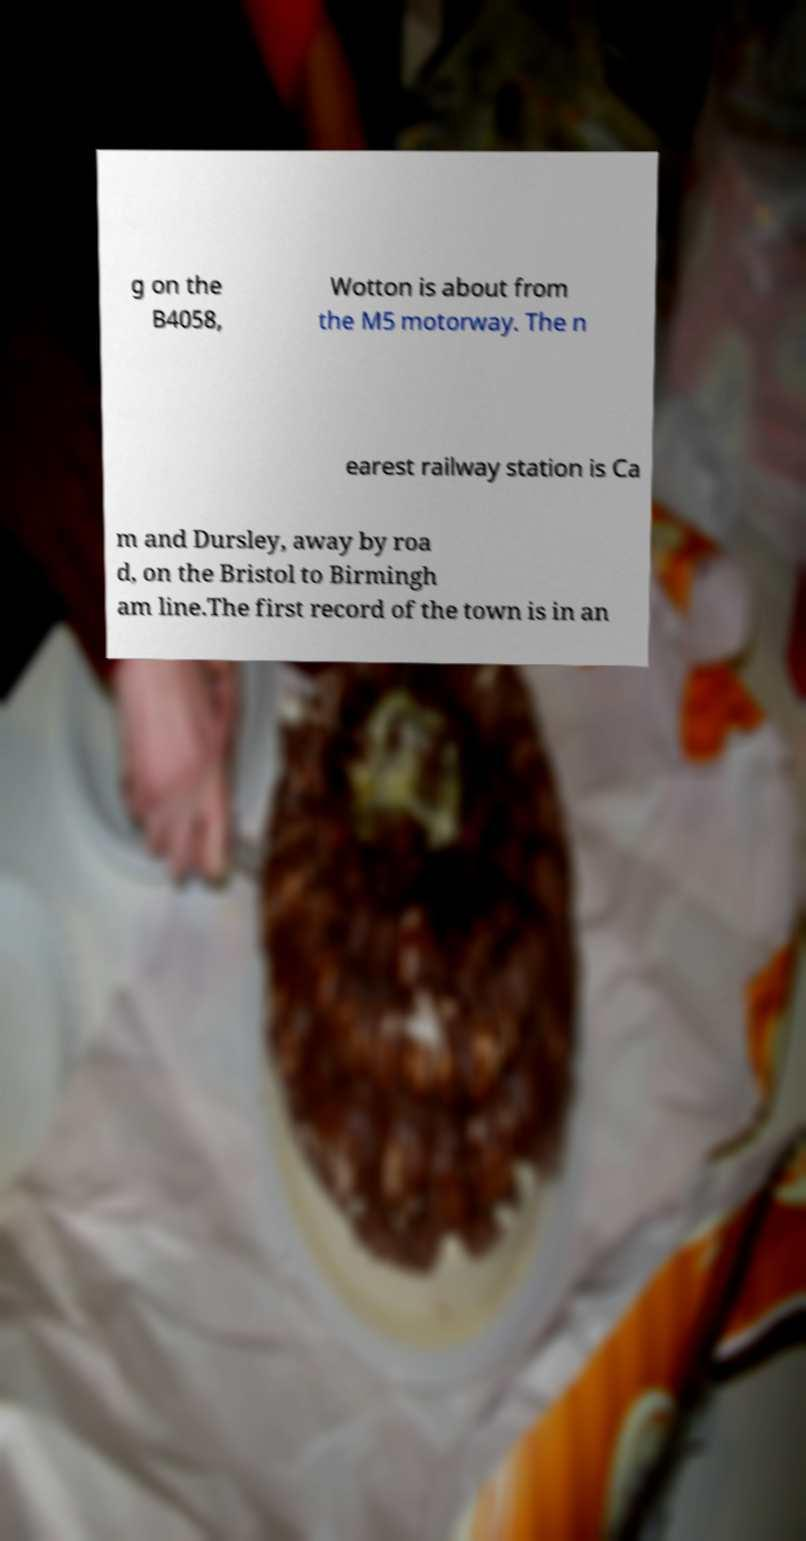Could you extract and type out the text from this image? g on the B4058, Wotton is about from the M5 motorway. The n earest railway station is Ca m and Dursley, away by roa d, on the Bristol to Birmingh am line.The first record of the town is in an 